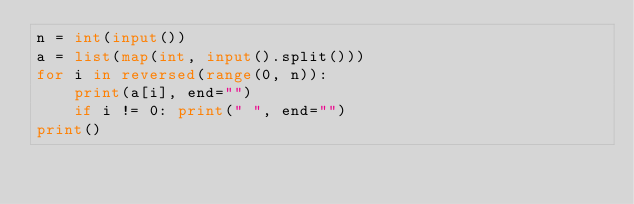Convert code to text. <code><loc_0><loc_0><loc_500><loc_500><_Python_>n = int(input())
a = list(map(int, input().split()))
for i in reversed(range(0, n)):
    print(a[i], end="")
    if i != 0: print(" ", end="")
print() 
</code> 